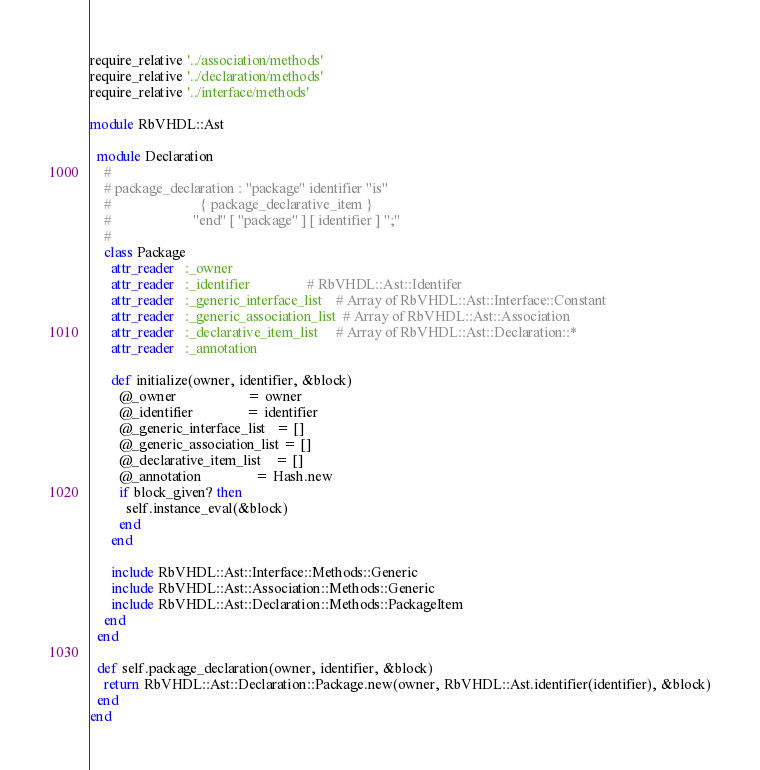Convert code to text. <code><loc_0><loc_0><loc_500><loc_500><_Ruby_>require_relative '../association/methods'
require_relative '../declaration/methods'
require_relative '../interface/methods'

module RbVHDL::Ast

  module Declaration
    #
    # package_declaration : "package" identifier "is"
    #                         { package_declarative_item }
    #                       "end" [ "package" ] [ identifier ] ";"
    #
    class Package
      attr_reader   :_owner
      attr_reader   :_identifier                # RbVHDL::Ast::Identifer
      attr_reader   :_generic_interface_list    # Array of RbVHDL::Ast::Interface::Constant
      attr_reader   :_generic_association_list  # Array of RbVHDL::Ast::Association
      attr_reader   :_declarative_item_list     # Array of RbVHDL::Ast::Declaration::*
      attr_reader   :_annotation
    
      def initialize(owner, identifier, &block)
        @_owner                    = owner
        @_identifier               = identifier
        @_generic_interface_list   = []
        @_generic_association_list = []
        @_declarative_item_list    = []
        @_annotation               = Hash.new
        if block_given? then
          self.instance_eval(&block)
        end
      end

      include RbVHDL::Ast::Interface::Methods::Generic
      include RbVHDL::Ast::Association::Methods::Generic
      include RbVHDL::Ast::Declaration::Methods::PackageItem
    end
  end

  def self.package_declaration(owner, identifier, &block)
    return RbVHDL::Ast::Declaration::Package.new(owner, RbVHDL::Ast.identifier(identifier), &block)
  end
end
</code> 